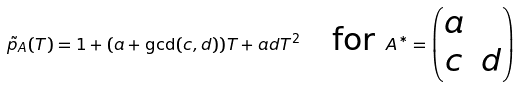<formula> <loc_0><loc_0><loc_500><loc_500>\tilde { p } _ { A } ( T ) = 1 + ( a + \gcd ( c , d ) ) T + a d T ^ { 2 } \quad \text {for } A ^ { * } = \left ( \begin{matrix} a \\ c & d \end{matrix} \right )</formula> 